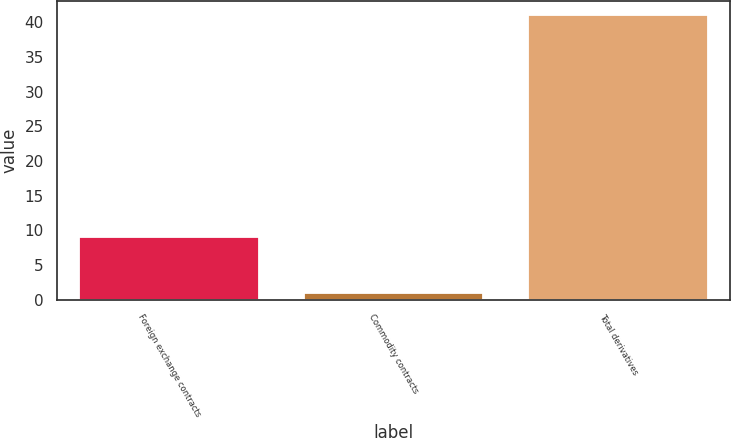Convert chart. <chart><loc_0><loc_0><loc_500><loc_500><bar_chart><fcel>Foreign exchange contracts<fcel>Commodity contracts<fcel>Total derivatives<nl><fcel>9<fcel>1<fcel>41<nl></chart> 